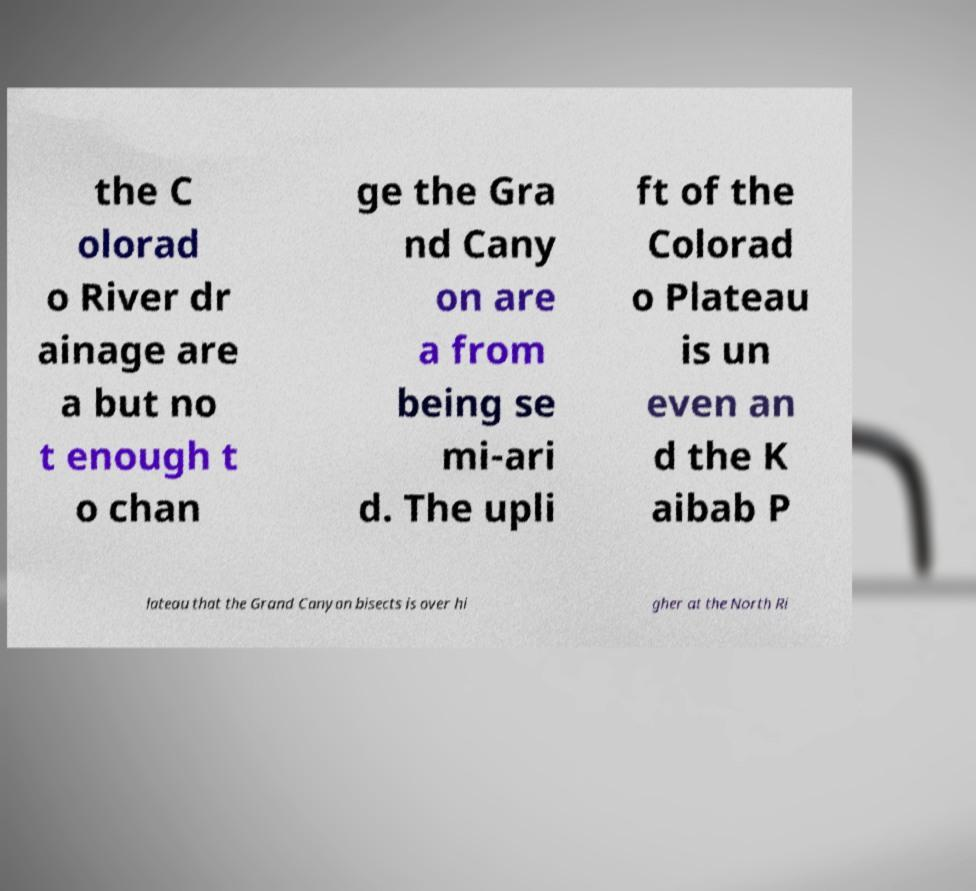Can you accurately transcribe the text from the provided image for me? the C olorad o River dr ainage are a but no t enough t o chan ge the Gra nd Cany on are a from being se mi-ari d. The upli ft of the Colorad o Plateau is un even an d the K aibab P lateau that the Grand Canyon bisects is over hi gher at the North Ri 